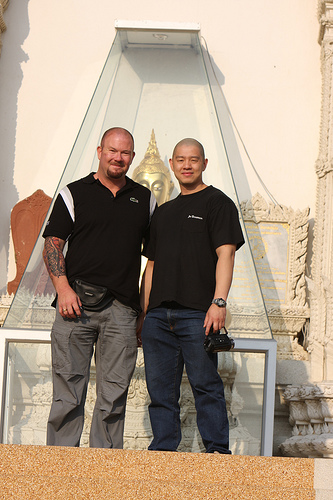<image>
Is there a shirt on the guy? No. The shirt is not positioned on the guy. They may be near each other, but the shirt is not supported by or resting on top of the guy. Is there a man to the left of the man? Yes. From this viewpoint, the man is positioned to the left side relative to the man. 